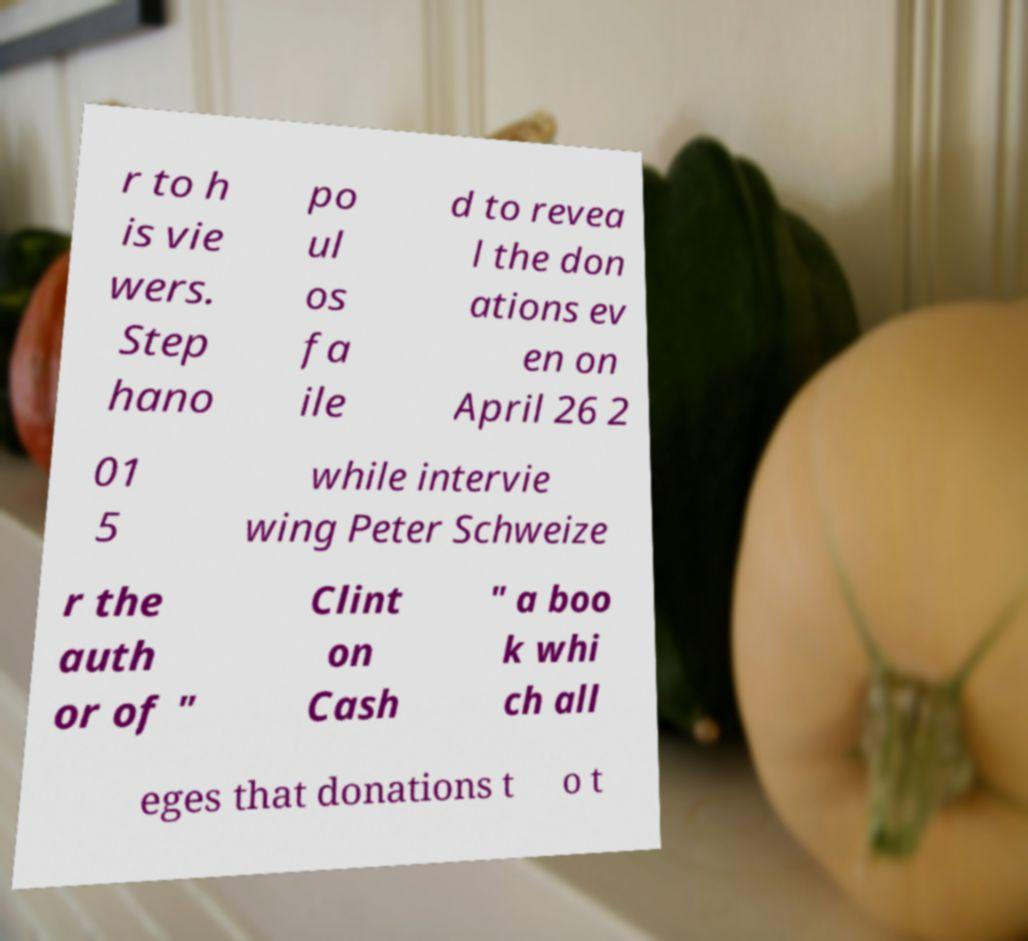Could you assist in decoding the text presented in this image and type it out clearly? r to h is vie wers. Step hano po ul os fa ile d to revea l the don ations ev en on April 26 2 01 5 while intervie wing Peter Schweize r the auth or of " Clint on Cash " a boo k whi ch all eges that donations t o t 